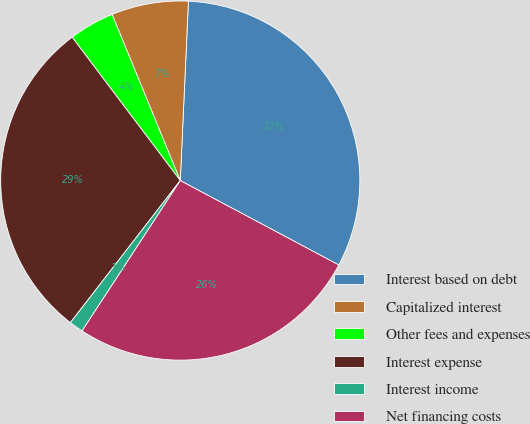Convert chart to OTSL. <chart><loc_0><loc_0><loc_500><loc_500><pie_chart><fcel>Interest based on debt<fcel>Capitalized interest<fcel>Other fees and expenses<fcel>Interest expense<fcel>Interest income<fcel>Net financing costs<nl><fcel>32.07%<fcel>6.92%<fcel>4.09%<fcel>29.24%<fcel>1.27%<fcel>26.42%<nl></chart> 